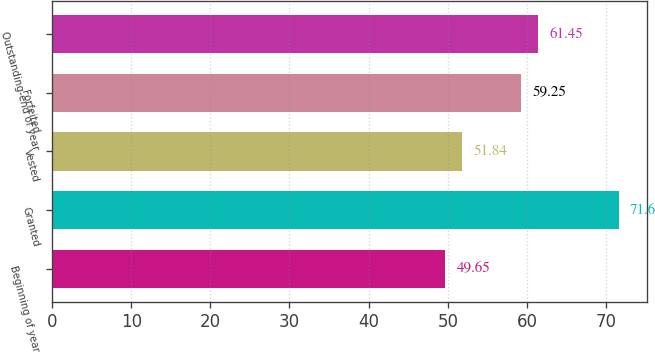<chart> <loc_0><loc_0><loc_500><loc_500><bar_chart><fcel>Beginning of year<fcel>Granted<fcel>Vested<fcel>Forfeited<fcel>Outstanding-end of year<nl><fcel>49.65<fcel>71.6<fcel>51.84<fcel>59.25<fcel>61.45<nl></chart> 